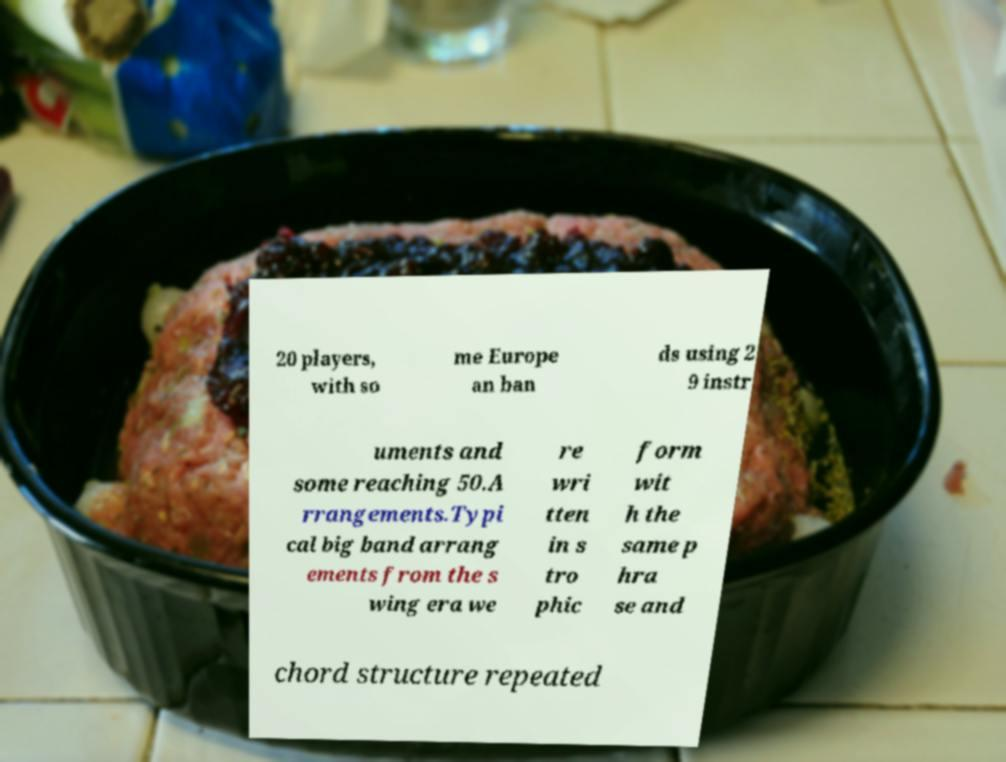There's text embedded in this image that I need extracted. Can you transcribe it verbatim? 20 players, with so me Europe an ban ds using 2 9 instr uments and some reaching 50.A rrangements.Typi cal big band arrang ements from the s wing era we re wri tten in s tro phic form wit h the same p hra se and chord structure repeated 